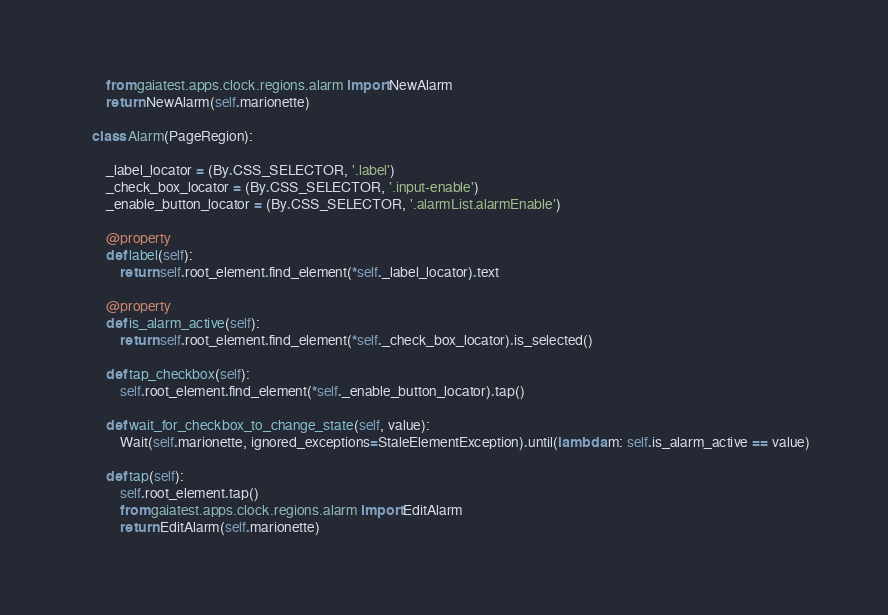<code> <loc_0><loc_0><loc_500><loc_500><_Python_>        from gaiatest.apps.clock.regions.alarm import NewAlarm
        return NewAlarm(self.marionette)

    class Alarm(PageRegion):

        _label_locator = (By.CSS_SELECTOR, '.label')
        _check_box_locator = (By.CSS_SELECTOR, '.input-enable')
        _enable_button_locator = (By.CSS_SELECTOR, '.alarmList.alarmEnable')

        @property
        def label(self):
            return self.root_element.find_element(*self._label_locator).text

        @property
        def is_alarm_active(self):
            return self.root_element.find_element(*self._check_box_locator).is_selected()

        def tap_checkbox(self):
            self.root_element.find_element(*self._enable_button_locator).tap()

        def wait_for_checkbox_to_change_state(self, value):
            Wait(self.marionette, ignored_exceptions=StaleElementException).until(lambda m: self.is_alarm_active == value)

        def tap(self):
            self.root_element.tap()
            from gaiatest.apps.clock.regions.alarm import EditAlarm
            return EditAlarm(self.marionette)
</code> 